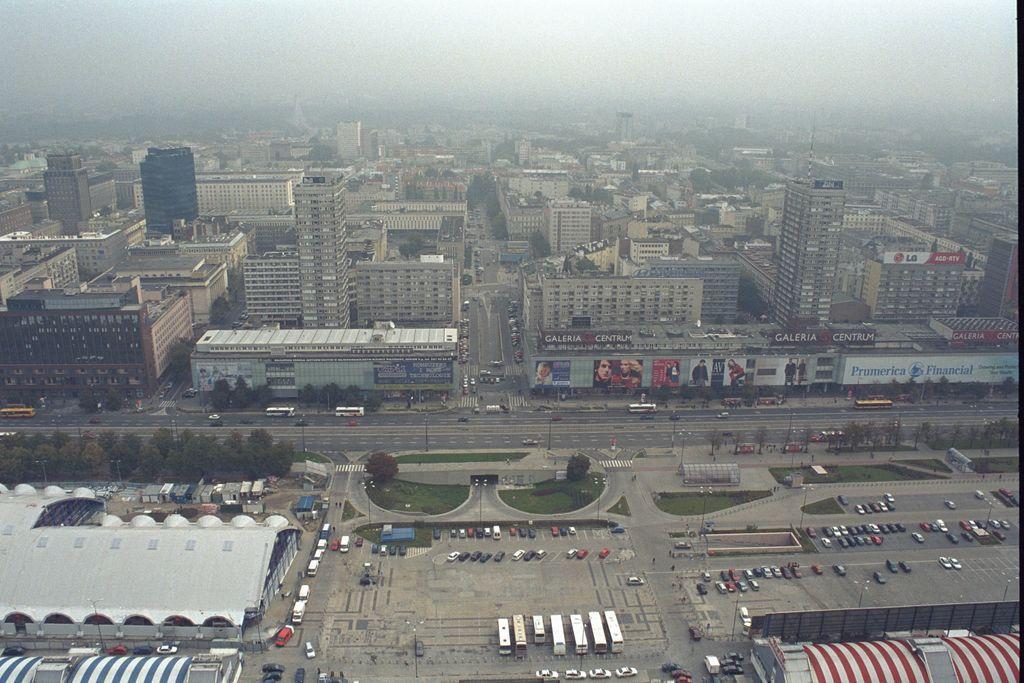Can you describe this image briefly? This image is an aerial view. In this image we can see many buildings and trees. At the bottom there are vehicles and we can see roads. At the top there is sky. 